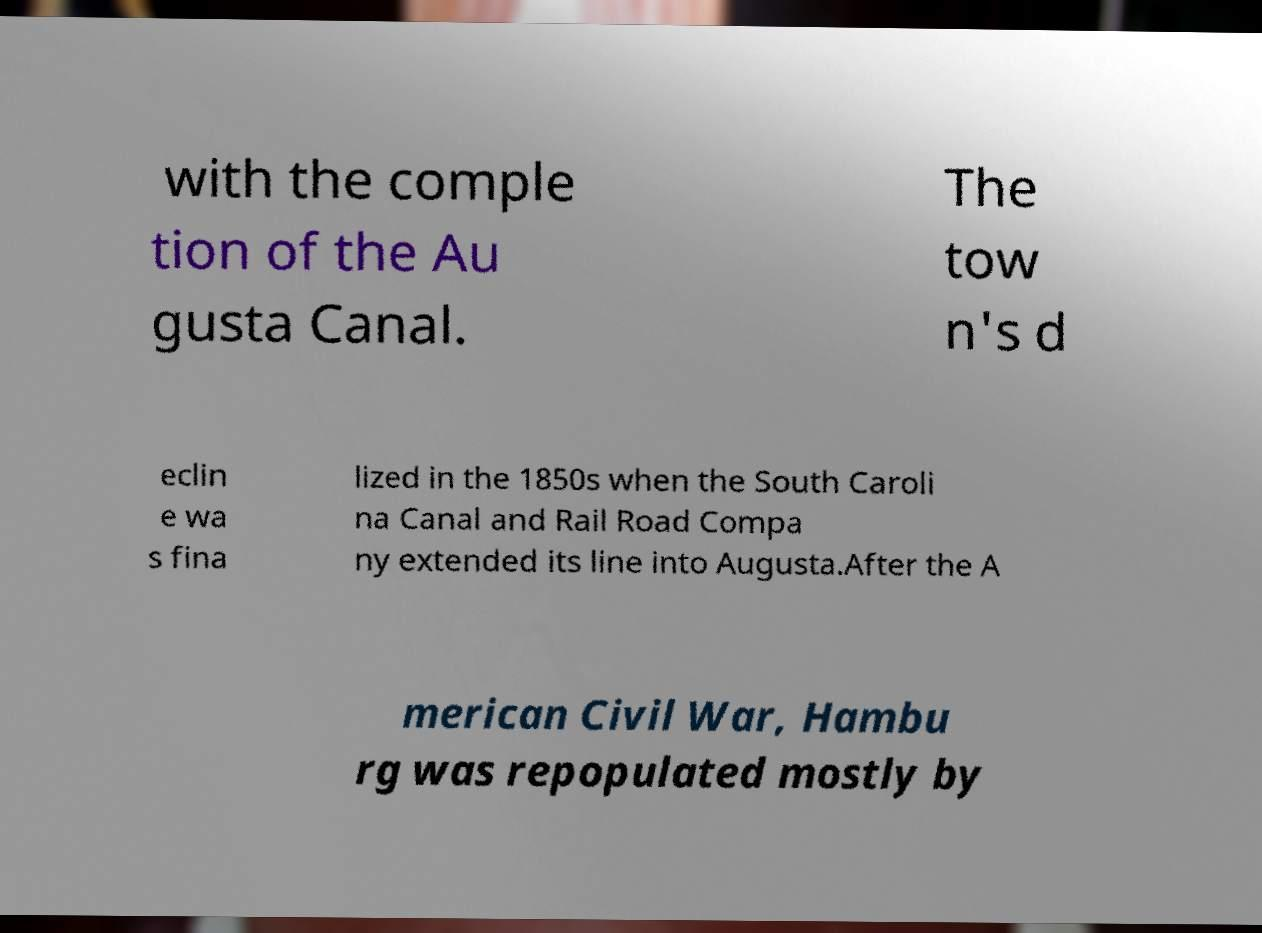There's text embedded in this image that I need extracted. Can you transcribe it verbatim? with the comple tion of the Au gusta Canal. The tow n's d eclin e wa s fina lized in the 1850s when the South Caroli na Canal and Rail Road Compa ny extended its line into Augusta.After the A merican Civil War, Hambu rg was repopulated mostly by 